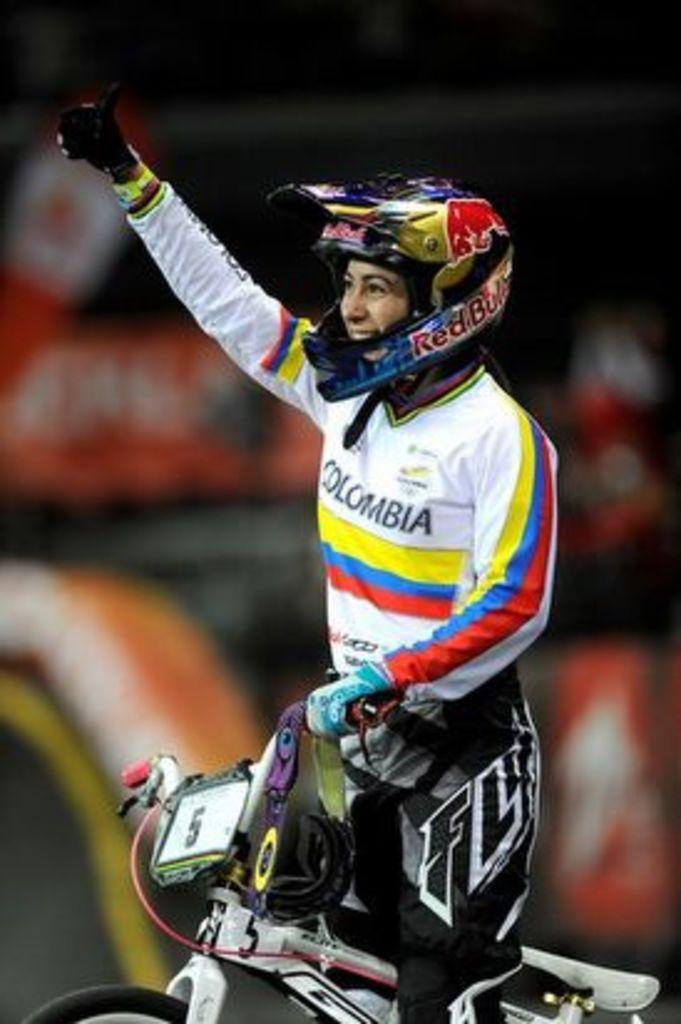In one or two sentences, can you explain what this image depicts? In the center of the image we can see person on a bicycle. 